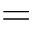Convert formula to latex. <formula><loc_0><loc_0><loc_500><loc_500>=</formula> 